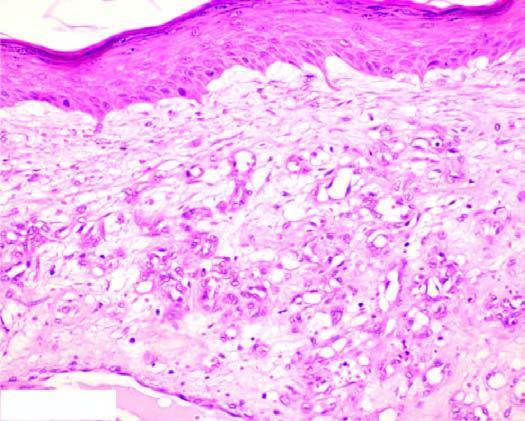what are there lined by plump endothelial cells and containing blood?
Answer the question using a single word or phrase. Capillaries 